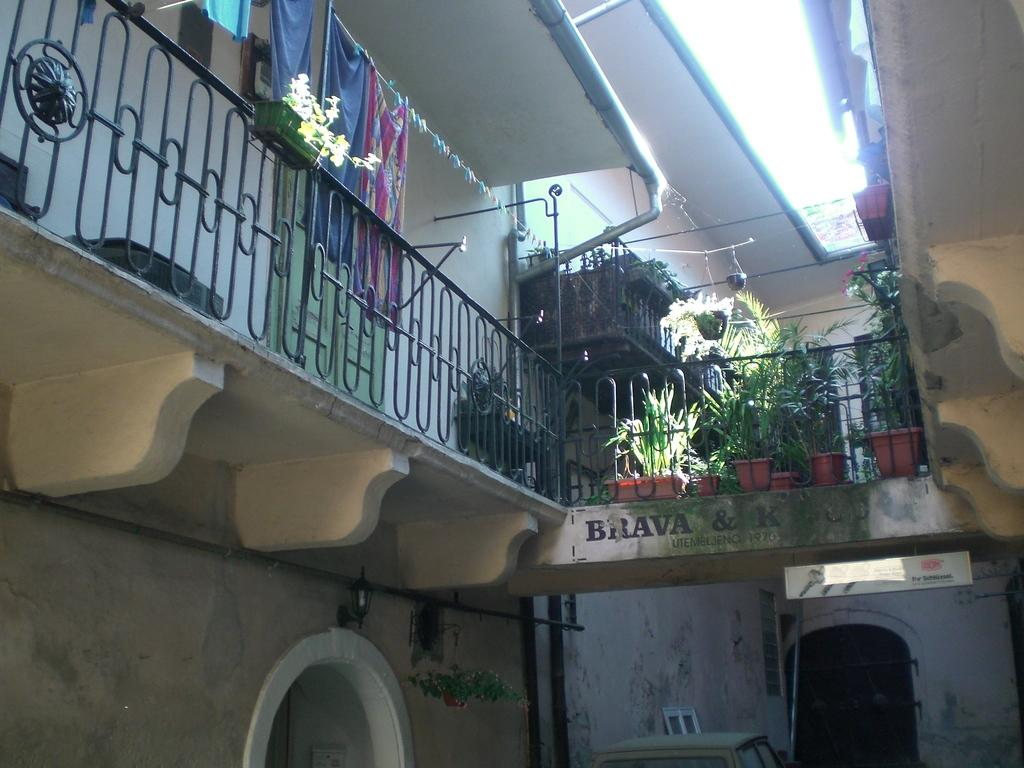What type of structure is visible in the image? There is a building in the image. What is located near the building? There is a fence in the image. What type of plants can be seen in the image? There are house plants in the image. What else is present in the image besides the building, fence, and plants? Clothes are present in the image. What type of juice is being served in the image? There is no juice present in the image. What property is being discussed in the image? The image does not depict a discussion about any property. 